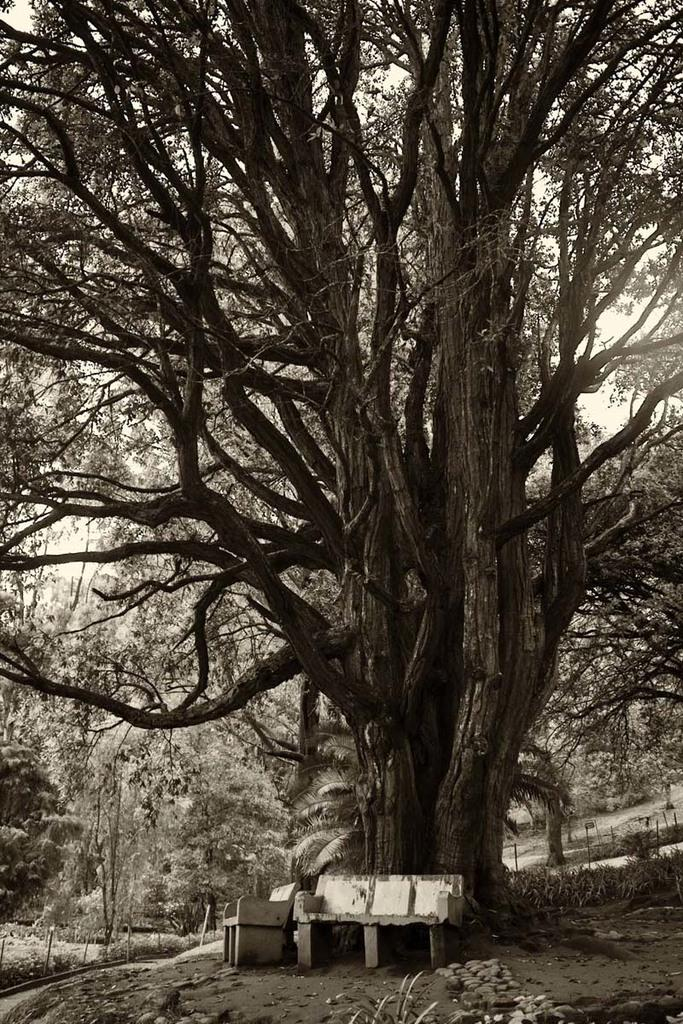What is located in the middle of the image? There are trees in the middle of the image. What can be found at the bottom of the image? There are benches and plants at the bottom of the image. What type of surface is visible at the bottom of the image? There is land visible at the bottom of the image. What is visible at the top of the image? The sky is visible at the top of the image. What type of scarf is being used as a sail in the image? There is no scarf or sail present in the image; it features trees, benches, plants, land, and the sky. 